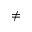<formula> <loc_0><loc_0><loc_500><loc_500>\neq</formula> 